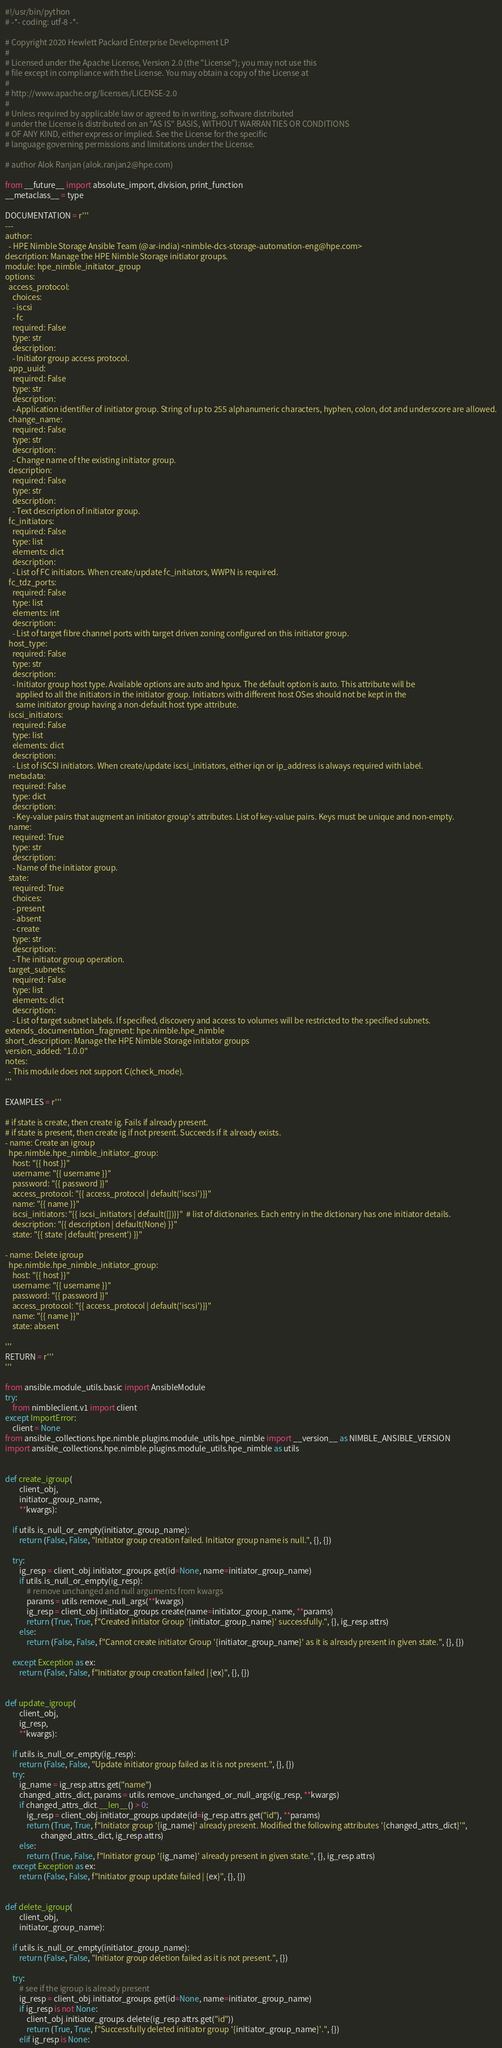Convert code to text. <code><loc_0><loc_0><loc_500><loc_500><_Python_>#!/usr/bin/python
# -*- coding: utf-8 -*-

# Copyright 2020 Hewlett Packard Enterprise Development LP
#
# Licensed under the Apache License, Version 2.0 (the "License"); you may not use this
# file except in compliance with the License. You may obtain a copy of the License at
#
# http://www.apache.org/licenses/LICENSE-2.0
#
# Unless required by applicable law or agreed to in writing, software distributed
# under the License is distributed on an "AS IS" BASIS, WITHOUT WARRANTIES OR CONDITIONS
# OF ANY KIND, either express or implied. See the License for the specific
# language governing permissions and limitations under the License.

# author Alok Ranjan (alok.ranjan2@hpe.com)

from __future__ import absolute_import, division, print_function
__metaclass__ = type

DOCUMENTATION = r'''
---
author:
  - HPE Nimble Storage Ansible Team (@ar-india) <nimble-dcs-storage-automation-eng@hpe.com>
description: Manage the HPE Nimble Storage initiator groups.
module: hpe_nimble_initiator_group
options:
  access_protocol:
    choices:
    - iscsi
    - fc
    required: False
    type: str
    description:
    - Initiator group access protocol.
  app_uuid:
    required: False
    type: str
    description:
    - Application identifier of initiator group. String of up to 255 alphanumeric characters, hyphen, colon, dot and underscore are allowed.
  change_name:
    required: False
    type: str
    description:
    - Change name of the existing initiator group.
  description:
    required: False
    type: str
    description:
    - Text description of initiator group.
  fc_initiators:
    required: False
    type: list
    elements: dict
    description:
    - List of FC initiators. When create/update fc_initiators, WWPN is required.
  fc_tdz_ports:
    required: False
    type: list
    elements: int
    description:
    - List of target fibre channel ports with target driven zoning configured on this initiator group.
  host_type:
    required: False
    type: str
    description:
    - Initiator group host type. Available options are auto and hpux. The default option is auto. This attribute will be
      applied to all the initiators in the initiator group. Initiators with different host OSes should not be kept in the
      same initiator group having a non-default host type attribute.
  iscsi_initiators:
    required: False
    type: list
    elements: dict
    description:
    - List of iSCSI initiators. When create/update iscsi_initiators, either iqn or ip_address is always required with label.
  metadata:
    required: False
    type: dict
    description:
    - Key-value pairs that augment an initiator group's attributes. List of key-value pairs. Keys must be unique and non-empty.
  name:
    required: True
    type: str
    description:
    - Name of the initiator group.
  state:
    required: True
    choices:
    - present
    - absent
    - create
    type: str
    description:
    - The initiator group operation.
  target_subnets:
    required: False
    type: list
    elements: dict
    description:
    - List of target subnet labels. If specified, discovery and access to volumes will be restricted to the specified subnets.
extends_documentation_fragment: hpe.nimble.hpe_nimble
short_description: Manage the HPE Nimble Storage initiator groups
version_added: "1.0.0"
notes:
  - This module does not support C(check_mode).
'''

EXAMPLES = r'''

# if state is create, then create ig. Fails if already present.
# if state is present, then create ig if not present. Succeeds if it already exists.
- name: Create an igroup
  hpe.nimble.hpe_nimble_initiator_group:
    host: "{{ host }}"
    username: "{{ username }}"
    password: "{{ password }}"
    access_protocol: "{{ access_protocol | default('iscsi')}}"
    name: "{{ name }}"
    iscsi_initiators: "{{ iscsi_initiators | default([])}}"  # list of dictionaries. Each entry in the dictionary has one initiator details.
    description: "{{ description | default(None) }}"
    state: "{{ state | default('present') }}"

- name: Delete igroup
  hpe.nimble.hpe_nimble_initiator_group:
    host: "{{ host }}"
    username: "{{ username }}"
    password: "{{ password }}"
    access_protocol: "{{ access_protocol | default('iscsi')}}"
    name: "{{ name }}"
    state: absent

'''
RETURN = r'''
'''

from ansible.module_utils.basic import AnsibleModule
try:
    from nimbleclient.v1 import client
except ImportError:
    client = None
from ansible_collections.hpe.nimble.plugins.module_utils.hpe_nimble import __version__ as NIMBLE_ANSIBLE_VERSION
import ansible_collections.hpe.nimble.plugins.module_utils.hpe_nimble as utils


def create_igroup(
        client_obj,
        initiator_group_name,
        **kwargs):

    if utils.is_null_or_empty(initiator_group_name):
        return (False, False, "Initiator group creation failed. Initiator group name is null.", {}, {})

    try:
        ig_resp = client_obj.initiator_groups.get(id=None, name=initiator_group_name)
        if utils.is_null_or_empty(ig_resp):
            # remove unchanged and null arguments from kwargs
            params = utils.remove_null_args(**kwargs)
            ig_resp = client_obj.initiator_groups.create(name=initiator_group_name, **params)
            return (True, True, f"Created initiator Group '{initiator_group_name}' successfully.", {}, ig_resp.attrs)
        else:
            return (False, False, f"Cannot create initiator Group '{initiator_group_name}' as it is already present in given state.", {}, {})

    except Exception as ex:
        return (False, False, f"Initiator group creation failed | {ex}", {}, {})


def update_igroup(
        client_obj,
        ig_resp,
        **kwargs):

    if utils.is_null_or_empty(ig_resp):
        return (False, False, "Update initiator group failed as it is not present.", {}, {})
    try:
        ig_name = ig_resp.attrs.get("name")
        changed_attrs_dict, params = utils.remove_unchanged_or_null_args(ig_resp, **kwargs)
        if changed_attrs_dict.__len__() > 0:
            ig_resp = client_obj.initiator_groups.update(id=ig_resp.attrs.get("id"), **params)
            return (True, True, f"Initiator group '{ig_name}' already present. Modified the following attributes '{changed_attrs_dict}'",
                    changed_attrs_dict, ig_resp.attrs)
        else:
            return (True, False, f"Initiator group '{ig_name}' already present in given state.", {}, ig_resp.attrs)
    except Exception as ex:
        return (False, False, f"Initiator group update failed | {ex}", {}, {})


def delete_igroup(
        client_obj,
        initiator_group_name):

    if utils.is_null_or_empty(initiator_group_name):
        return (False, False, "Initiator group deletion failed as it is not present.", {})

    try:
        # see if the igroup is already present
        ig_resp = client_obj.initiator_groups.get(id=None, name=initiator_group_name)
        if ig_resp is not None:
            client_obj.initiator_groups.delete(ig_resp.attrs.get("id"))
            return (True, True, f"Successfully deleted initiator group '{initiator_group_name}'.", {})
        elif ig_resp is None:</code> 